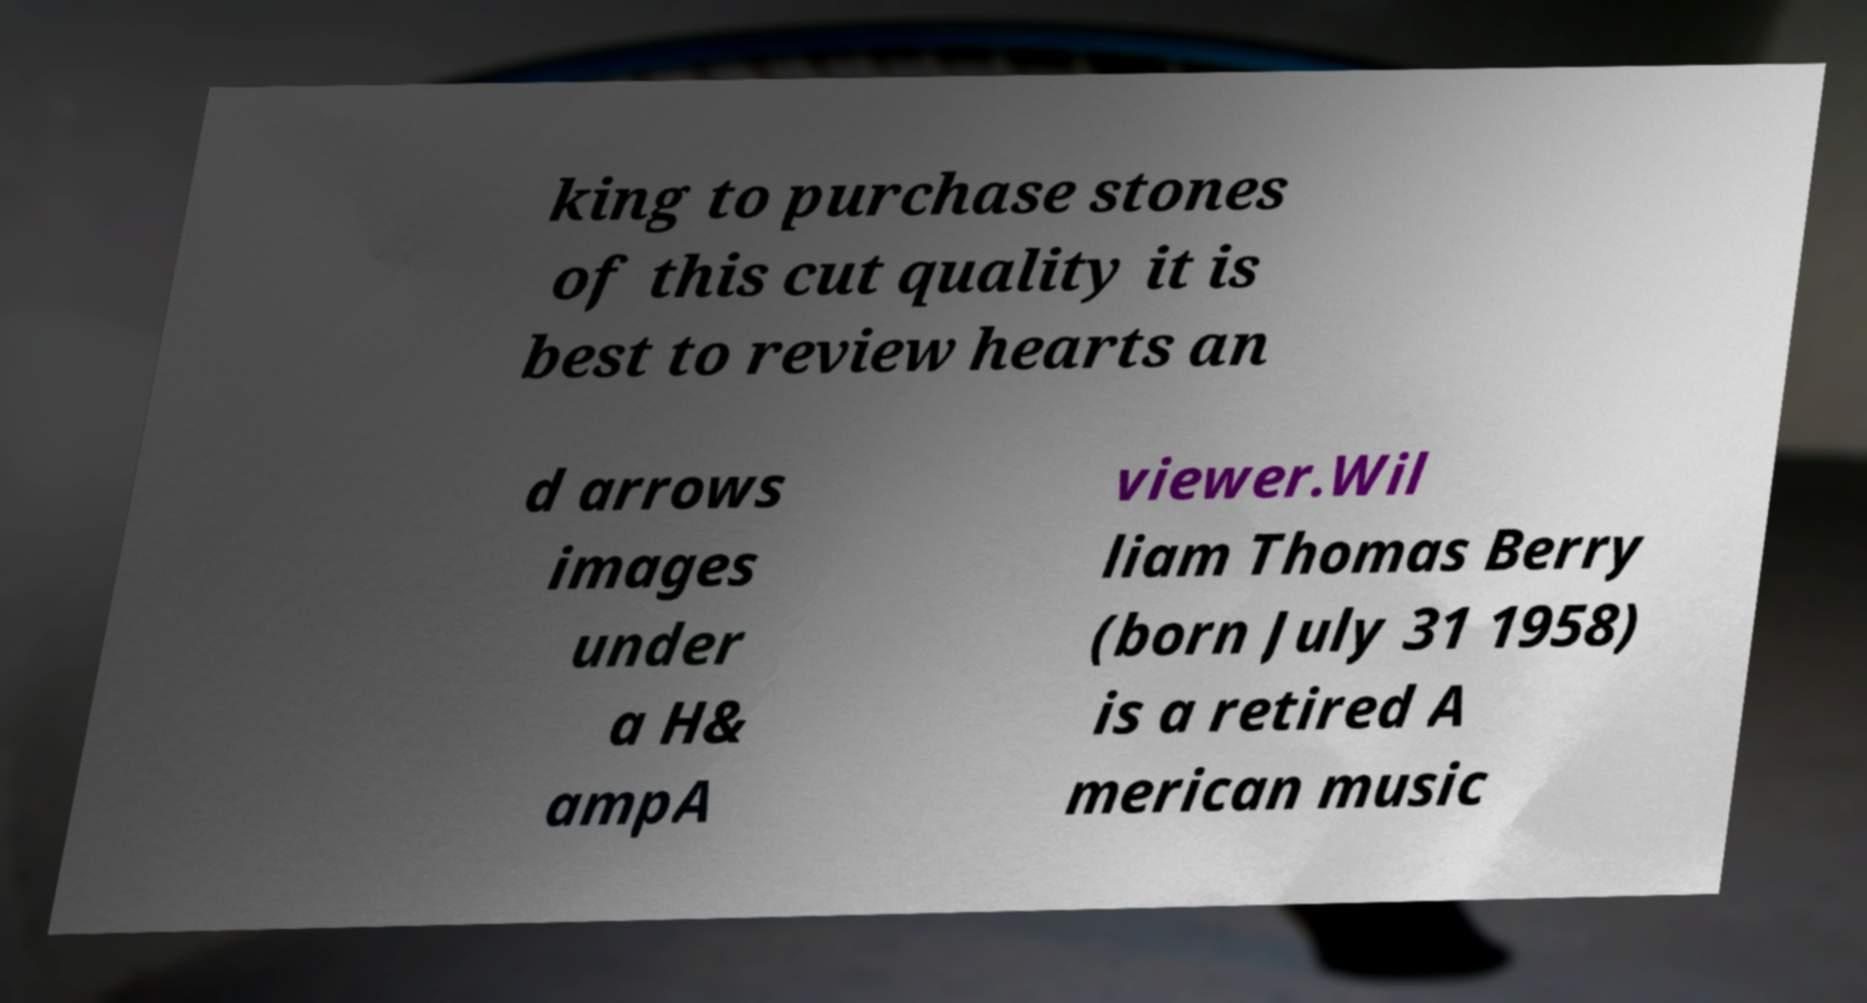Please read and relay the text visible in this image. What does it say? king to purchase stones of this cut quality it is best to review hearts an d arrows images under a H& ampA viewer.Wil liam Thomas Berry (born July 31 1958) is a retired A merican music 